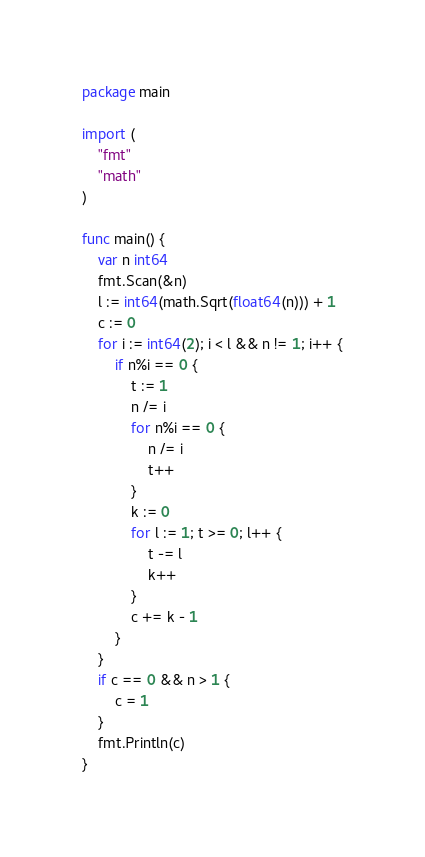Convert code to text. <code><loc_0><loc_0><loc_500><loc_500><_Go_>package main

import (
	"fmt"
	"math"
)

func main() {
	var n int64
	fmt.Scan(&n)
	l := int64(math.Sqrt(float64(n))) + 1
	c := 0
	for i := int64(2); i < l && n != 1; i++ {
		if n%i == 0 {
			t := 1
			n /= i
			for n%i == 0 {
				n /= i
				t++
			}
			k := 0
			for l := 1; t >= 0; l++ {
				t -= l
				k++
			}
			c += k - 1
		}
	}
	if c == 0 && n > 1 {
		c = 1
	}
	fmt.Println(c)
}
</code> 